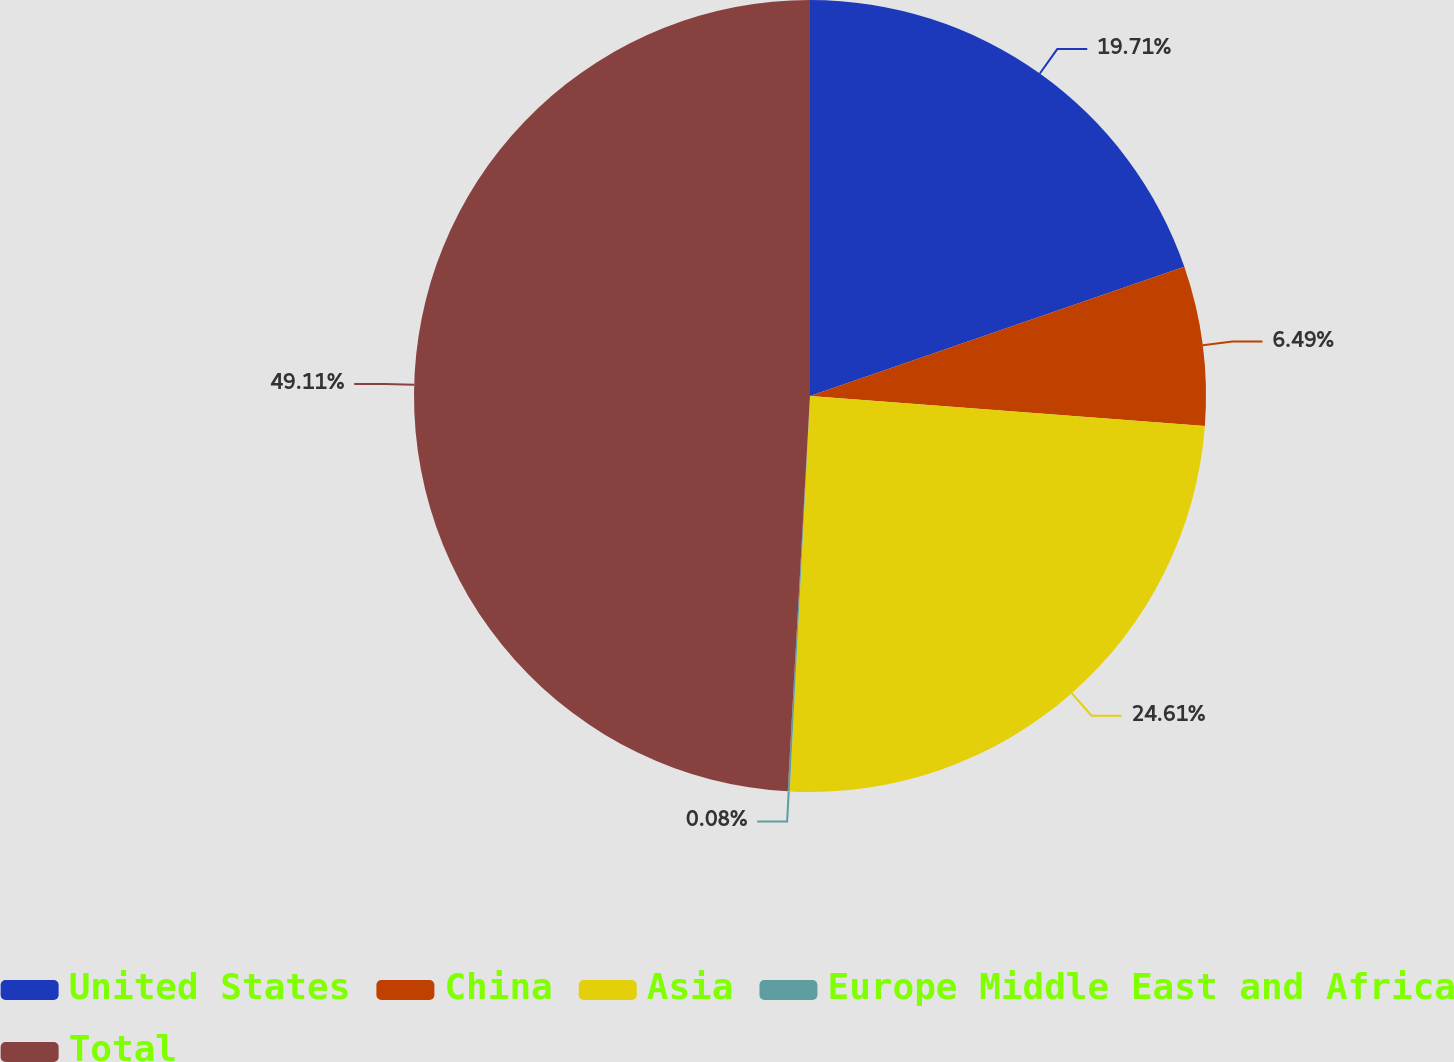Convert chart to OTSL. <chart><loc_0><loc_0><loc_500><loc_500><pie_chart><fcel>United States<fcel>China<fcel>Asia<fcel>Europe Middle East and Africa<fcel>Total<nl><fcel>19.71%<fcel>6.49%<fcel>24.61%<fcel>0.08%<fcel>49.1%<nl></chart> 